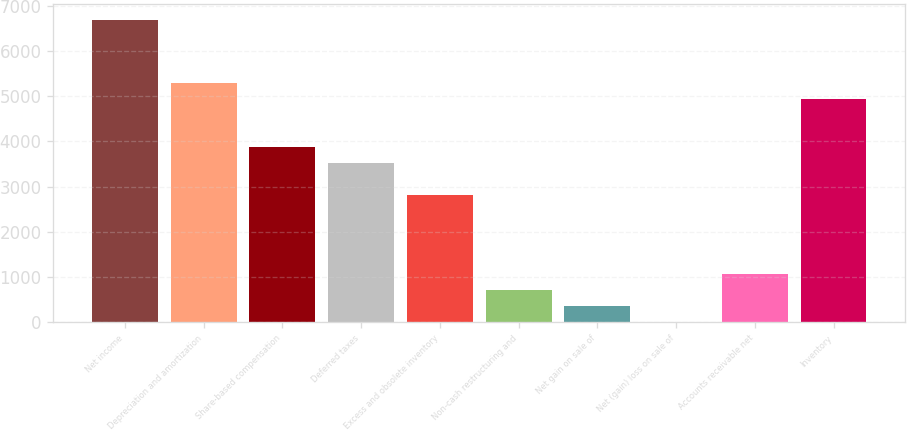Convert chart to OTSL. <chart><loc_0><loc_0><loc_500><loc_500><bar_chart><fcel>Net income<fcel>Depreciation and amortization<fcel>Share-based compensation<fcel>Deferred taxes<fcel>Excess and obsolete inventory<fcel>Non-cash restructuring and<fcel>Net gain on sale of<fcel>Net (gain) loss on sale of<fcel>Accounts receivable net<fcel>Inventory<nl><fcel>6699.5<fcel>5289.5<fcel>3879.5<fcel>3527<fcel>2822<fcel>707<fcel>354.5<fcel>2<fcel>1059.5<fcel>4937<nl></chart> 